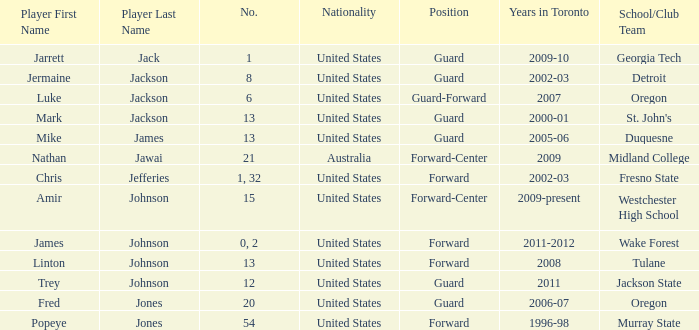What are the total number of positions on the Toronto team in 2006-07? 1.0. 